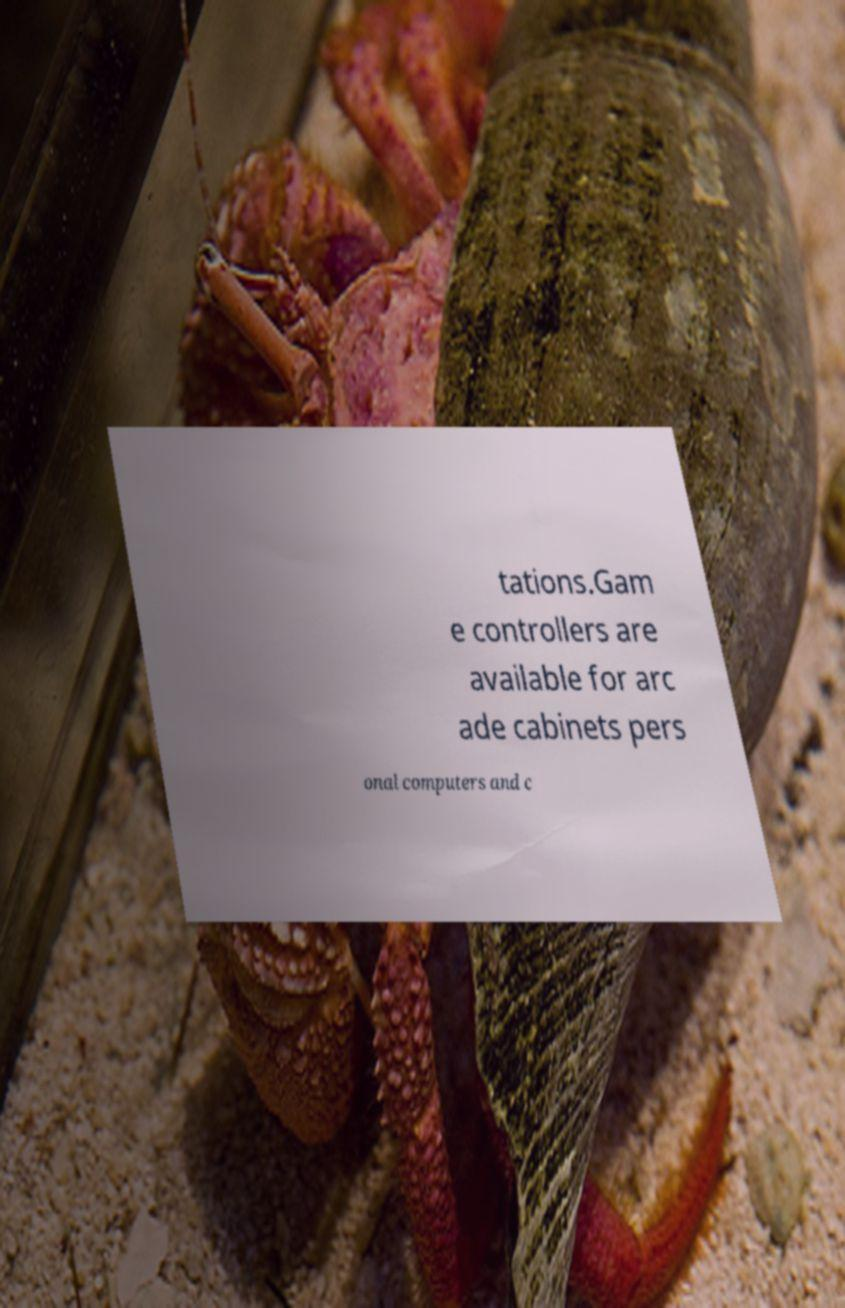Please read and relay the text visible in this image. What does it say? tations.Gam e controllers are available for arc ade cabinets pers onal computers and c 